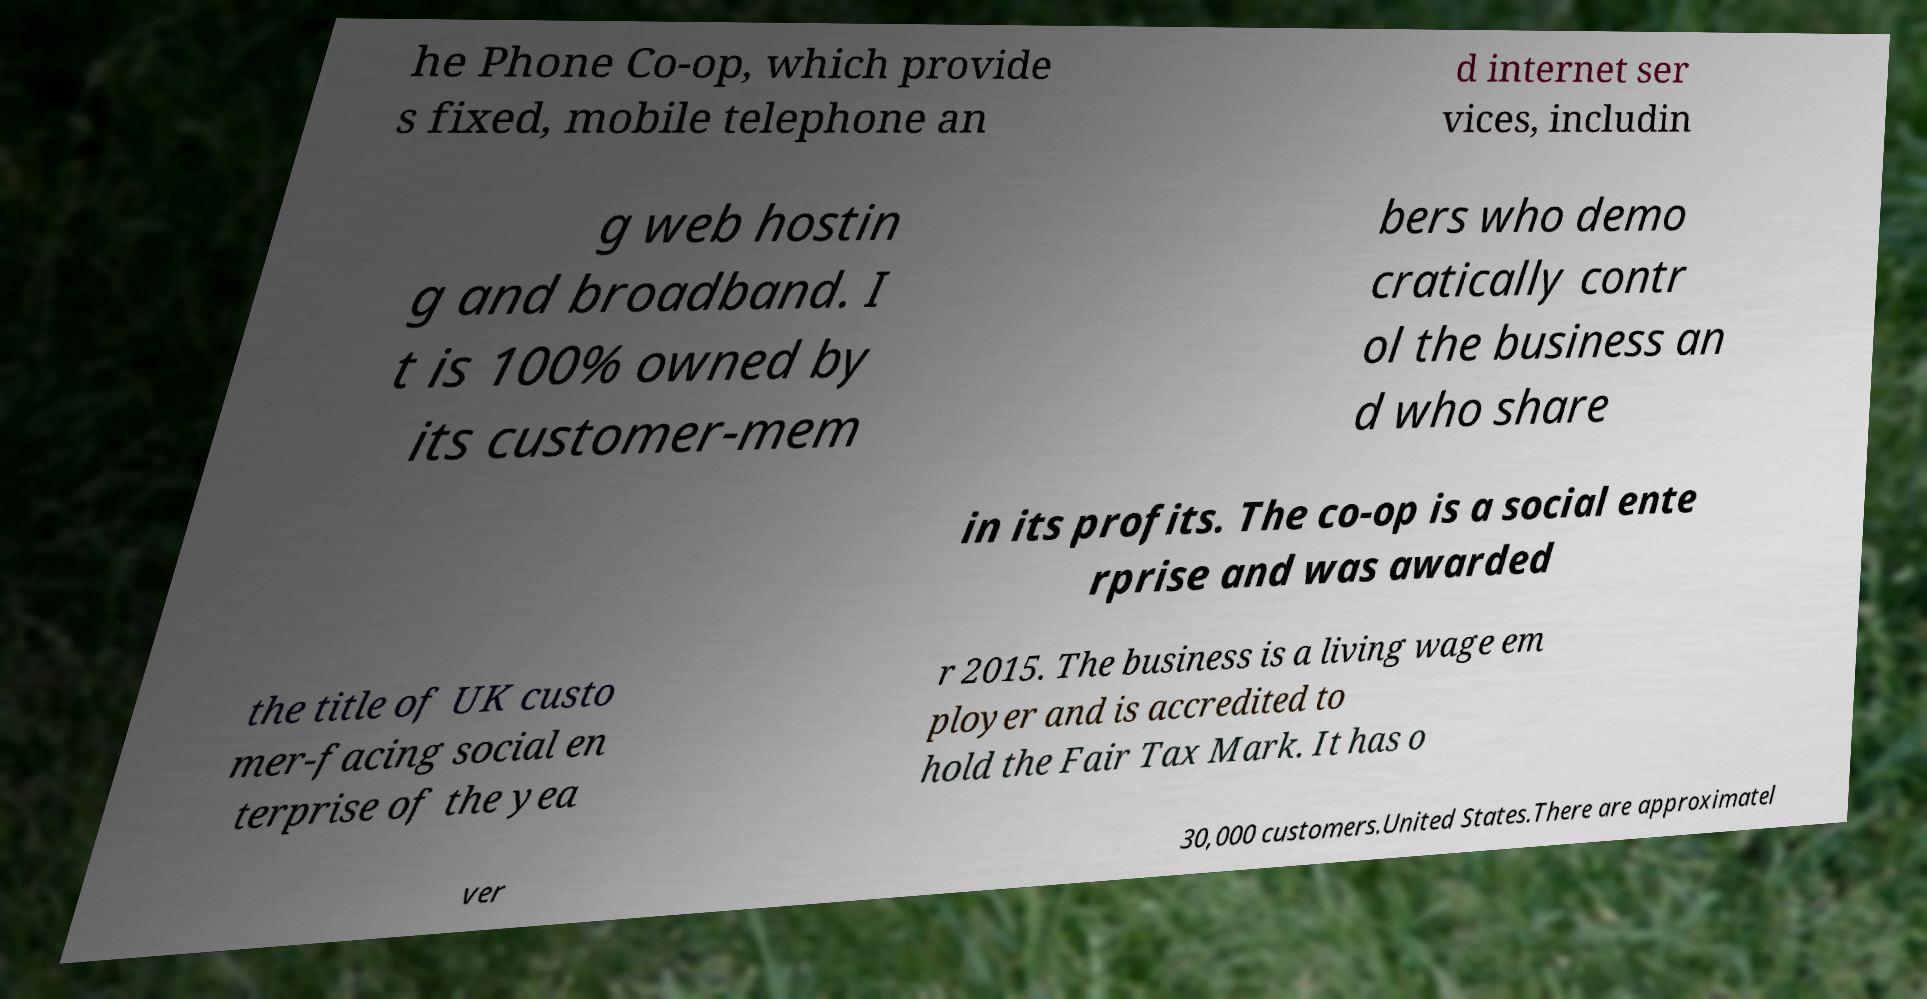For documentation purposes, I need the text within this image transcribed. Could you provide that? he Phone Co-op, which provide s fixed, mobile telephone an d internet ser vices, includin g web hostin g and broadband. I t is 100% owned by its customer-mem bers who demo cratically contr ol the business an d who share in its profits. The co-op is a social ente rprise and was awarded the title of UK custo mer-facing social en terprise of the yea r 2015. The business is a living wage em ployer and is accredited to hold the Fair Tax Mark. It has o ver 30,000 customers.United States.There are approximatel 